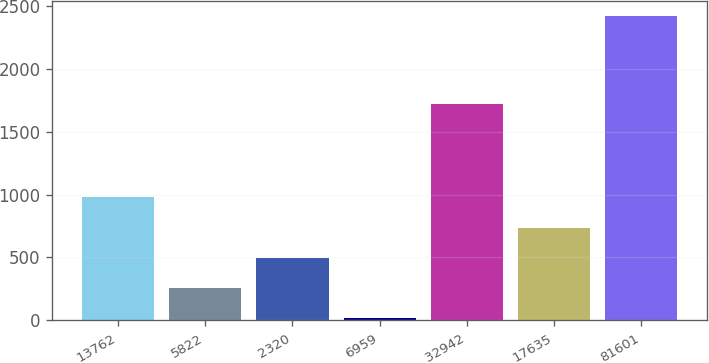Convert chart. <chart><loc_0><loc_0><loc_500><loc_500><bar_chart><fcel>13762<fcel>5822<fcel>2320<fcel>6959<fcel>32942<fcel>17635<fcel>81601<nl><fcel>978.6<fcel>257.4<fcel>497.8<fcel>17<fcel>1720<fcel>738.2<fcel>2421<nl></chart> 